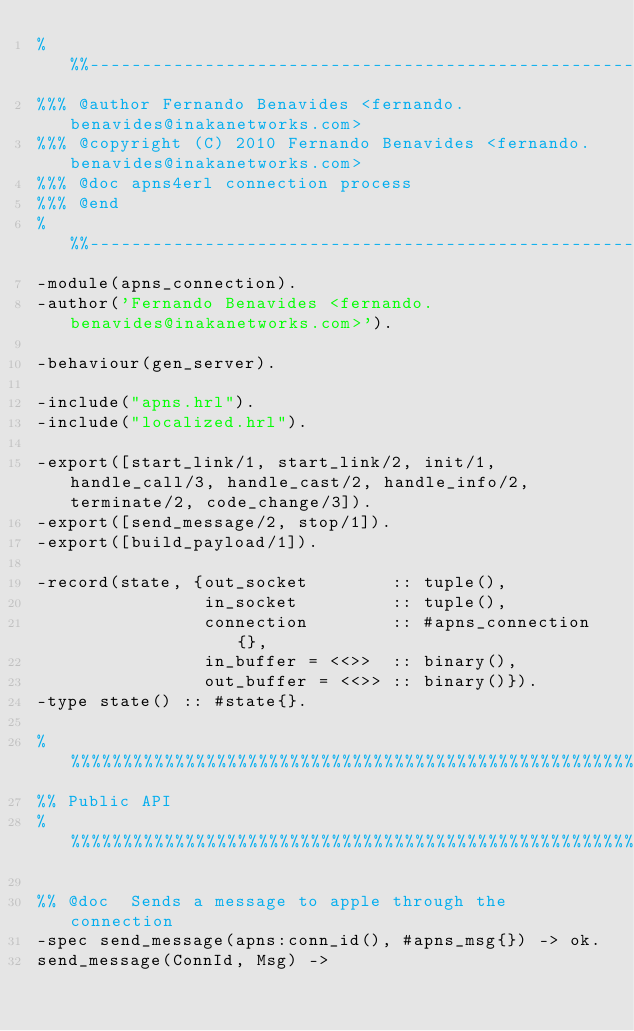Convert code to text. <code><loc_0><loc_0><loc_500><loc_500><_Erlang_>%%%-------------------------------------------------------------------
%%% @author Fernando Benavides <fernando.benavides@inakanetworks.com>
%%% @copyright (C) 2010 Fernando Benavides <fernando.benavides@inakanetworks.com>
%%% @doc apns4erl connection process
%%% @end
%%%-------------------------------------------------------------------
-module(apns_connection).
-author('Fernando Benavides <fernando.benavides@inakanetworks.com>').

-behaviour(gen_server).

-include("apns.hrl").
-include("localized.hrl").

-export([start_link/1, start_link/2, init/1, handle_call/3, handle_cast/2, handle_info/2, terminate/2, code_change/3]).
-export([send_message/2, stop/1]).
-export([build_payload/1]).

-record(state, {out_socket        :: tuple(),
                in_socket         :: tuple(),
                connection        :: #apns_connection{},
                in_buffer = <<>>  :: binary(),
                out_buffer = <<>> :: binary()}).
-type state() :: #state{}.

%%%%%%%%%%%%%%%%%%%%%%%%%%%%%%%%%%%%%%%%%%%%%%%%%%%%%%%%%%%%%%%%%%%%%%%%%%%%%%%%%%%%%%%%%%%%%%%%%%%%%%%%%%
%% Public API
%%%%%%%%%%%%%%%%%%%%%%%%%%%%%%%%%%%%%%%%%%%%%%%%%%%%%%%%%%%%%%%%%%%%%%%%%%%%%%%%%%%%%%%%%%%%%%%%%%%%%%%%%%

%% @doc  Sends a message to apple through the connection
-spec send_message(apns:conn_id(), #apns_msg{}) -> ok.
send_message(ConnId, Msg) -></code> 